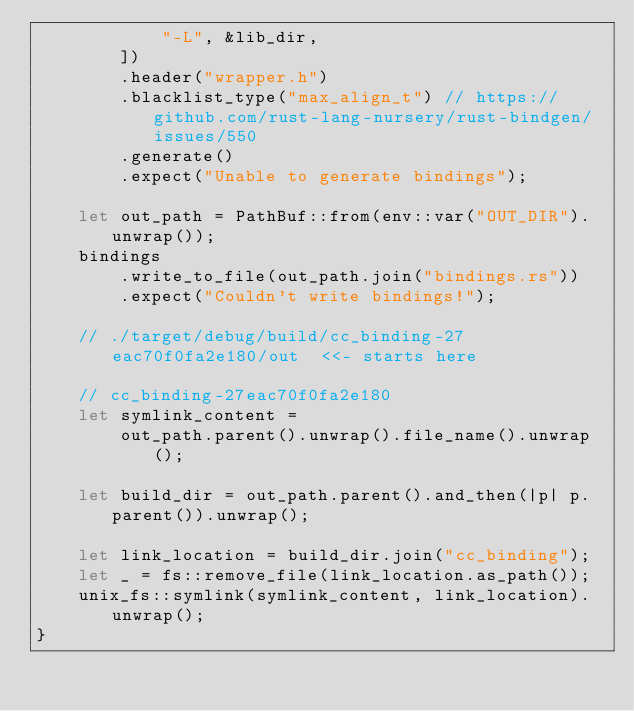Convert code to text. <code><loc_0><loc_0><loc_500><loc_500><_Rust_>            "-L", &lib_dir,
        ])
        .header("wrapper.h")
        .blacklist_type("max_align_t") // https://github.com/rust-lang-nursery/rust-bindgen/issues/550
        .generate()
        .expect("Unable to generate bindings");

    let out_path = PathBuf::from(env::var("OUT_DIR").unwrap());
    bindings
        .write_to_file(out_path.join("bindings.rs"))
        .expect("Couldn't write bindings!");

    // ./target/debug/build/cc_binding-27eac70f0fa2e180/out  <<- starts here

    // cc_binding-27eac70f0fa2e180
    let symlink_content =
        out_path.parent().unwrap().file_name().unwrap();

    let build_dir = out_path.parent().and_then(|p| p.parent()).unwrap();

    let link_location = build_dir.join("cc_binding");
    let _ = fs::remove_file(link_location.as_path());
    unix_fs::symlink(symlink_content, link_location).unwrap();
}

</code> 